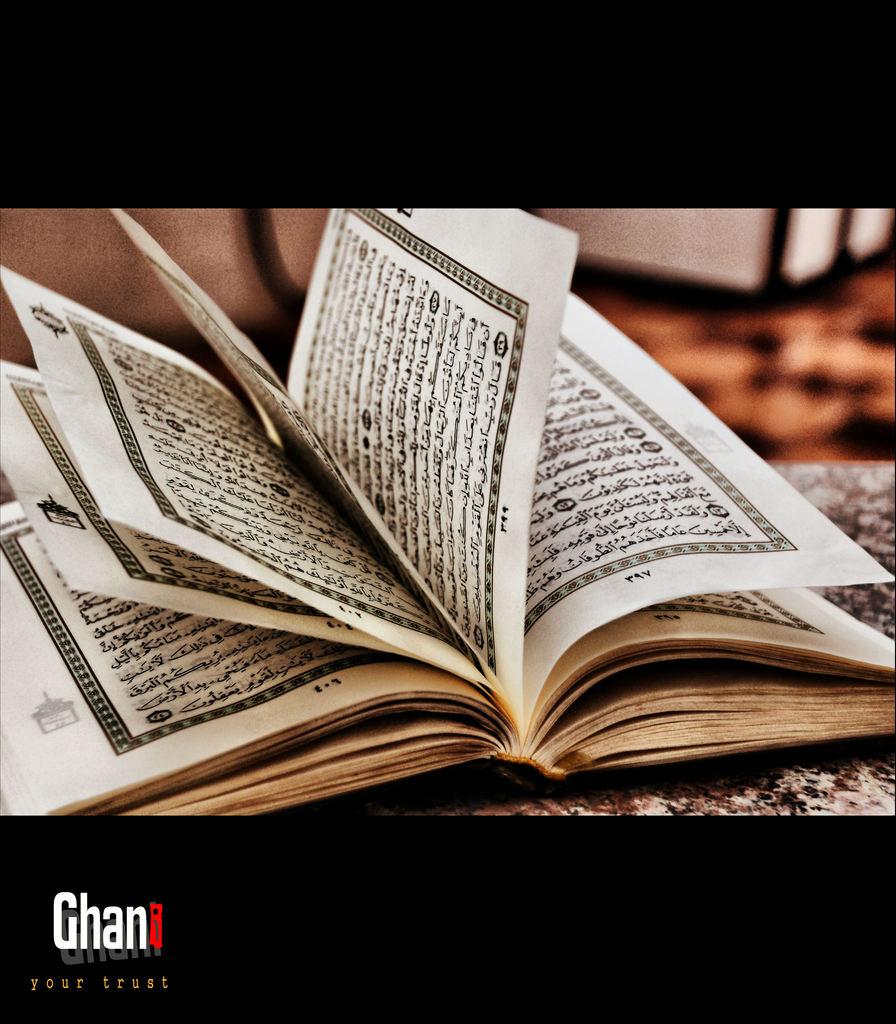What is written in the bottom of the picture?
Provide a short and direct response. Ghan. 